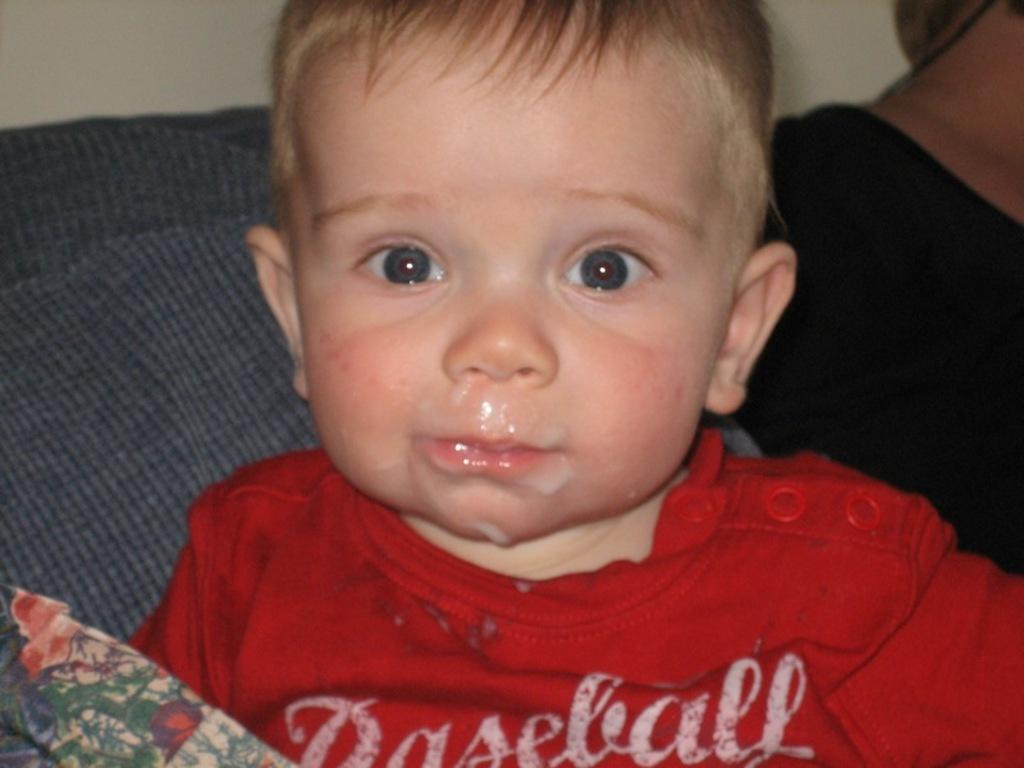Who is present in the image? There is a boy and a woman in the image. What is the boy wearing? The boy is wearing a red t-shirt. Where is the boy sitting? The boy is sitting on a couch. What type of canvas is the boy painting on in the image? There is no canvas present in the image, and the boy is not shown painting. 